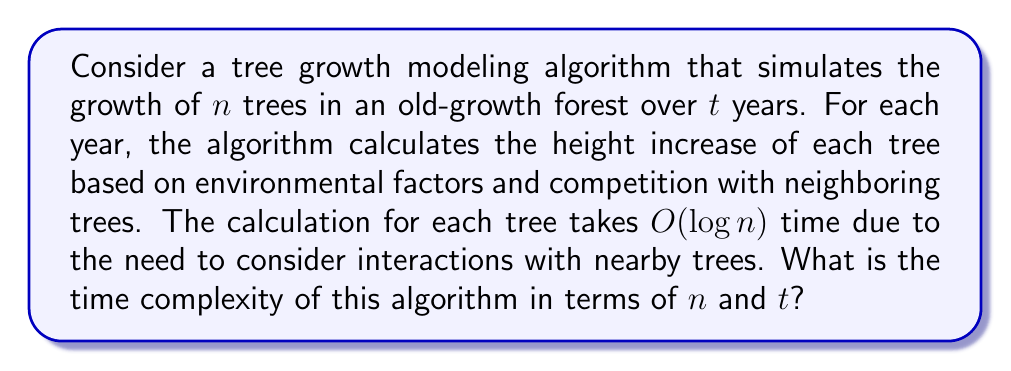Give your solution to this math problem. To analyze the time complexity of this algorithm, let's break it down step by step:

1. The algorithm simulates the growth for $t$ years.

2. For each year, it processes $n$ trees.

3. For each tree, the calculation takes $O(\log n)$ time.

Therefore, we can express the time complexity as follows:

$$T(n,t) = t \cdot n \cdot O(\log n)$$

This can be simplified to:

$$T(n,t) = O(t \cdot n \log n)$$

The reasoning behind this complexity:
- We have $t$ iterations for the years.
- In each iteration, we process $n$ trees.
- For each tree, we perform a $O(\log n)$ operation.

This algorithm's efficiency is particularly relevant for modeling old-growth forests, where the number of trees ($n$) can be very large, and the simulation may need to run for many years ($t$) to capture long-term ecosystem dynamics.

It's worth noting that this complexity assumes that the number of neighboring trees considered for each tree's growth calculation is proportional to $\log n$. This is a reasonable assumption in many forest models, as trees typically interact most strongly with a limited number of nearby neighbors, which increases logarithmically with the total number of trees in the forest.
Answer: $O(t \cdot n \log n)$ 